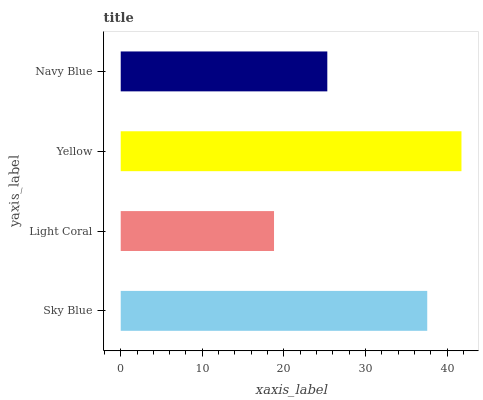Is Light Coral the minimum?
Answer yes or no. Yes. Is Yellow the maximum?
Answer yes or no. Yes. Is Yellow the minimum?
Answer yes or no. No. Is Light Coral the maximum?
Answer yes or no. No. Is Yellow greater than Light Coral?
Answer yes or no. Yes. Is Light Coral less than Yellow?
Answer yes or no. Yes. Is Light Coral greater than Yellow?
Answer yes or no. No. Is Yellow less than Light Coral?
Answer yes or no. No. Is Sky Blue the high median?
Answer yes or no. Yes. Is Navy Blue the low median?
Answer yes or no. Yes. Is Yellow the high median?
Answer yes or no. No. Is Sky Blue the low median?
Answer yes or no. No. 